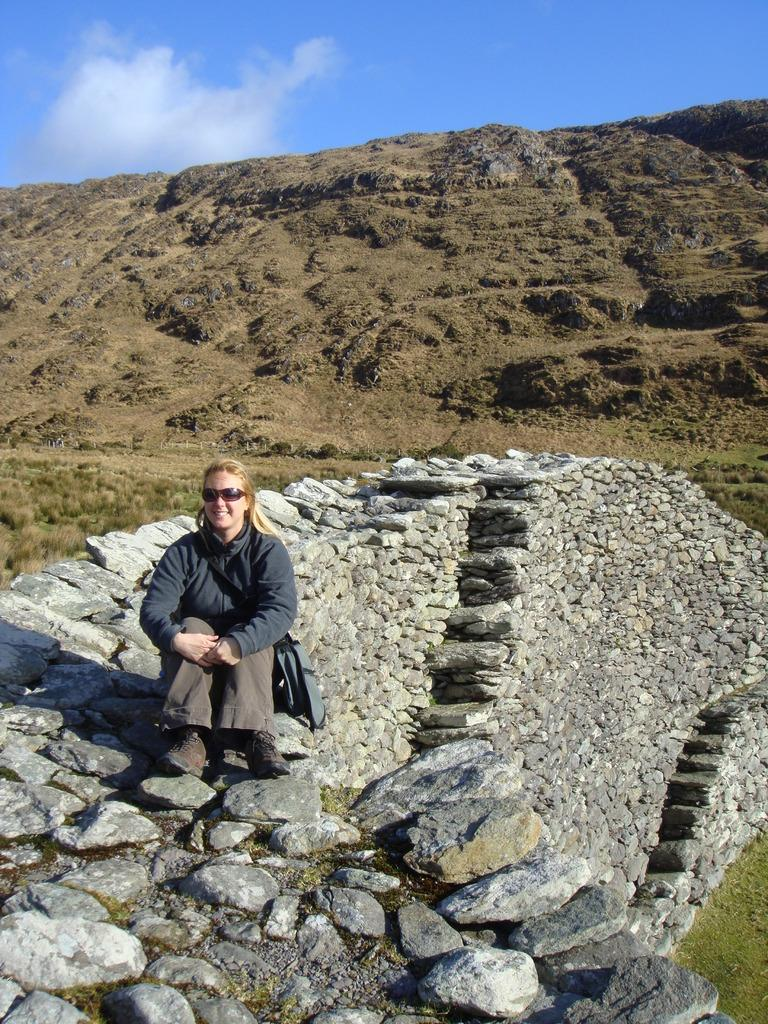Who or what is present in the image? There is a person in the image. What is the person wearing? The person is wearing a bag. Where is the person sitting? The person is sitting on a rock wall. What can be seen in the middle of the image? There is a hill in the middle of the image. What is visible at the top of the image? The sky is visible at the top of the image. Can you see any bees flying around the person in the image? There is no mention of bees in the image, so we cannot determine if any are present. Is the person in danger of sinking into quicksand in the image? There is no quicksand present in the image, so the person is not in danger of sinking into it. 